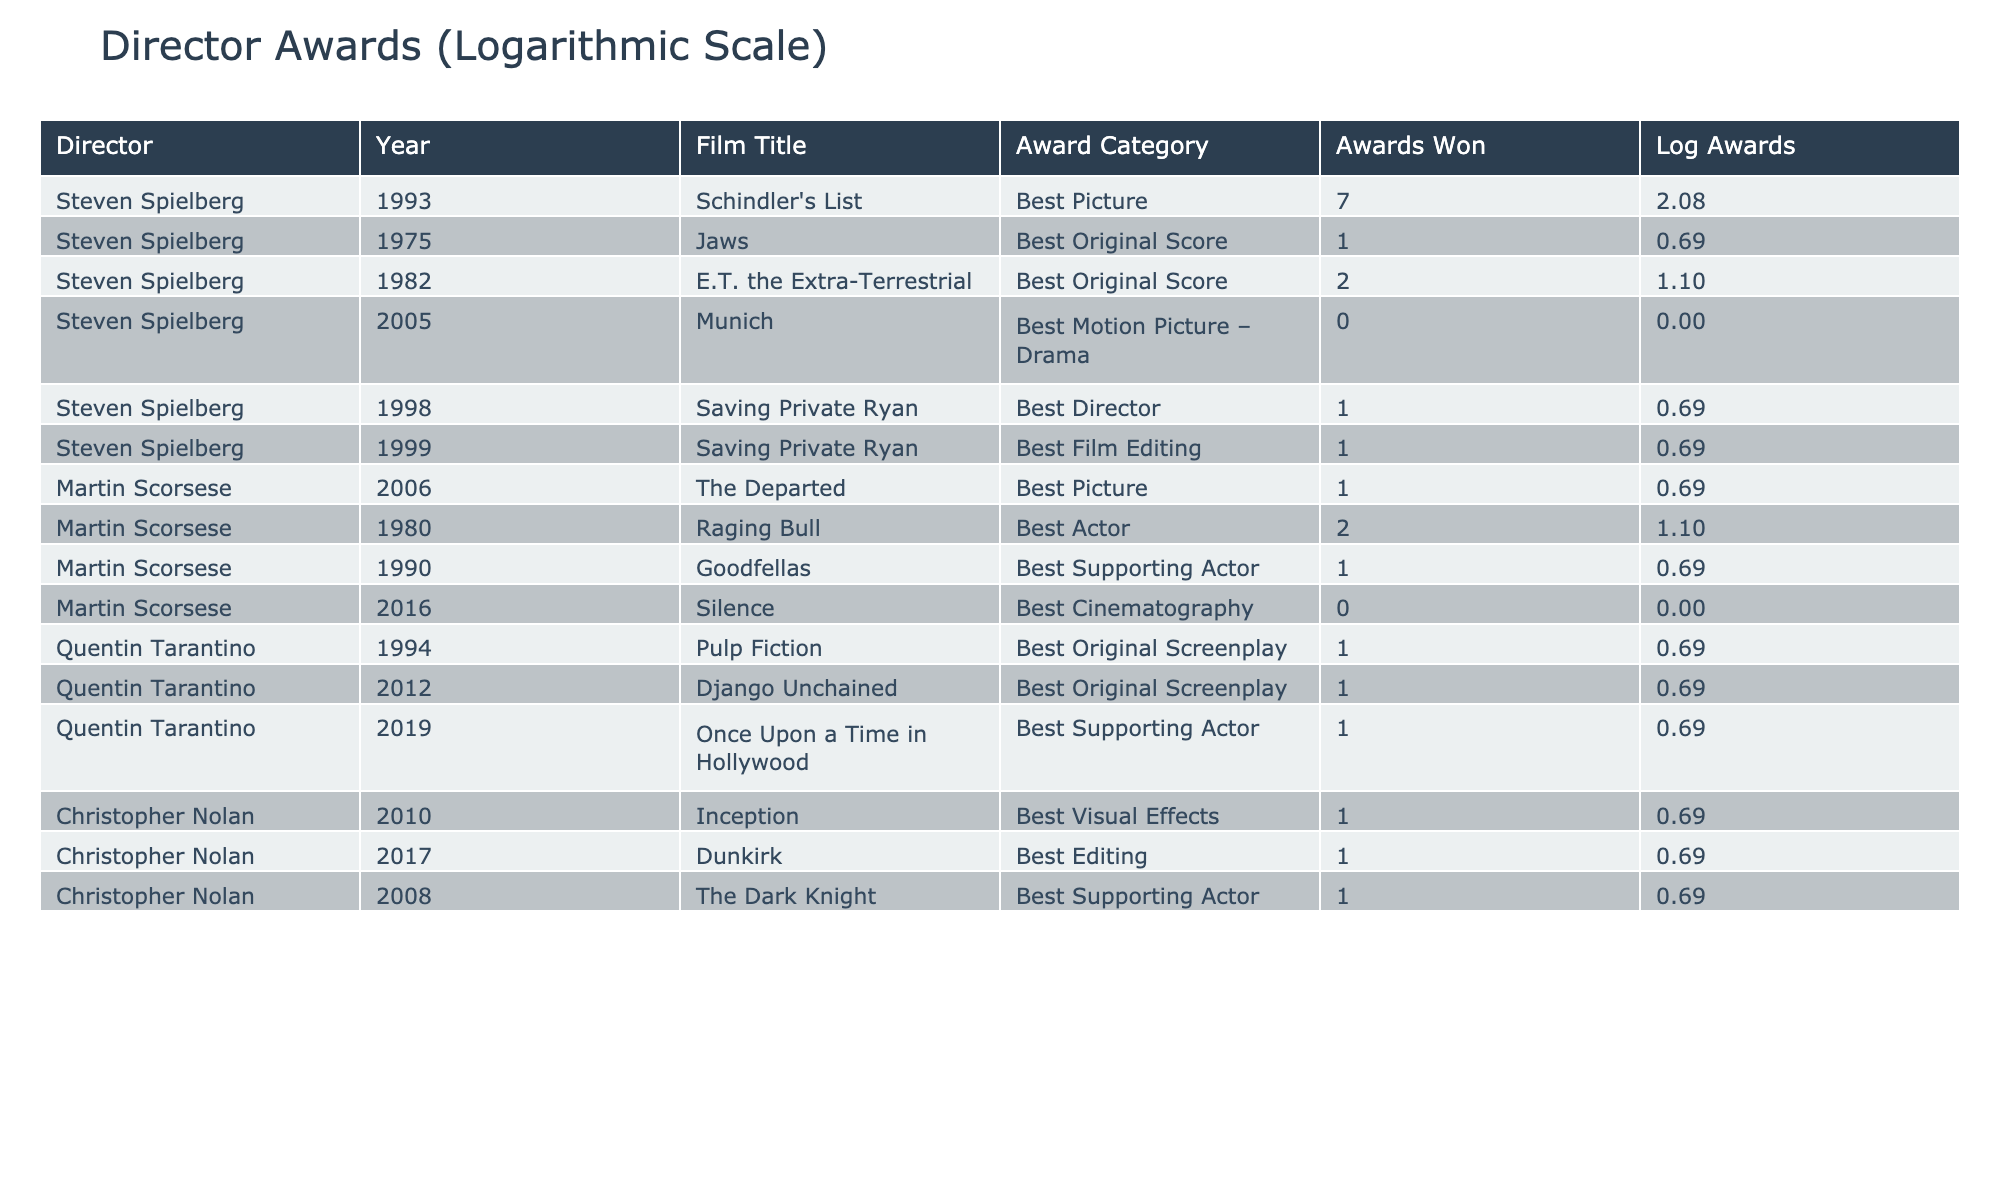What is the total number of awards won by Steven Spielberg's films? From the table, we can see that Spielberg's films won 7 (Schindler's List) + 1 (Jaws) + 2 (E.T. the Extra-Terrestrial) + 1 (Saving Private Ryan - Best Director) + 1 (Saving Private Ryan - Best Film Editing) = 12 awards in total.
Answer: 12 How many films by Martin Scorsese won zero awards? Looking at the table, there is 1 film (Silence) that has won 0 awards.
Answer: 1 What is the total number of awards won by Quentin Tarantino's films? Tarantino's films won 1 (Pulp Fiction) + 1 (Django Unchained) + 1 (Once Upon a Time in Hollywood) = 3 awards in total.
Answer: 3 Which director has the highest total number of awards won? Steven Spielberg has won 12 awards (from the previous calculations), while Martin Scorsese has 6 awards (1 + 2 + 1 + 0) and Quentin Tarantino has 3 awards. Therefore, Spielberg is the director with the highest total.
Answer: Steven Spielberg Is it true that all of Christopher Nolan's films shown in the table won at least one award? Christopher Nolan's films (Inception, Dunkirk, The Dark Knight) each won exactly one award, meaning they all won awards, so the statement is true.
Answer: Yes 